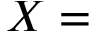<formula> <loc_0><loc_0><loc_500><loc_500>X =</formula> 